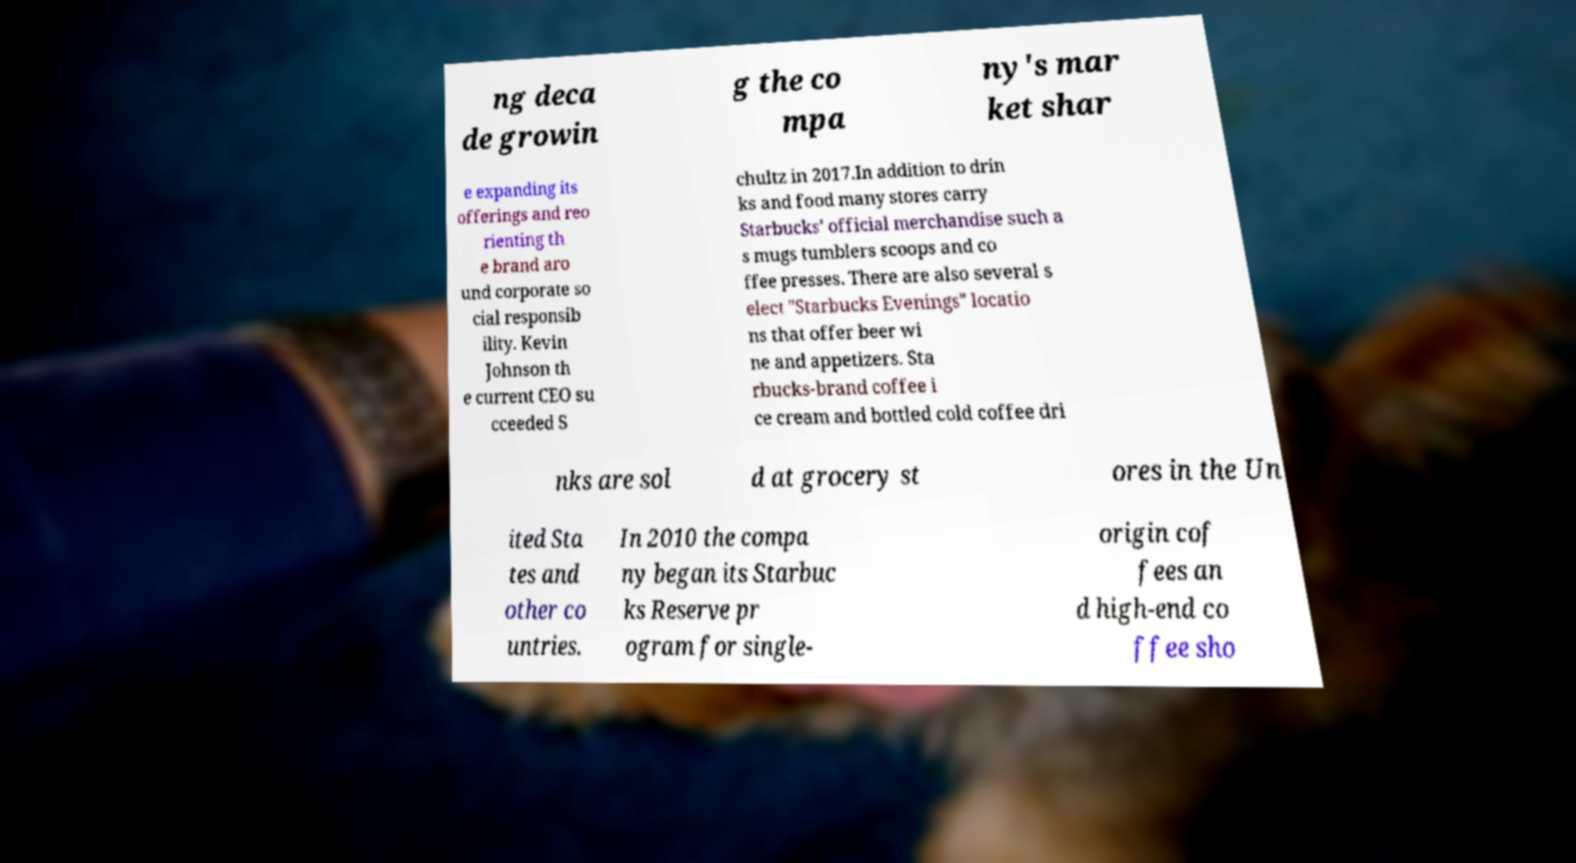Could you extract and type out the text from this image? ng deca de growin g the co mpa ny's mar ket shar e expanding its offerings and reo rienting th e brand aro und corporate so cial responsib ility. Kevin Johnson th e current CEO su cceeded S chultz in 2017.In addition to drin ks and food many stores carry Starbucks' official merchandise such a s mugs tumblers scoops and co ffee presses. There are also several s elect "Starbucks Evenings" locatio ns that offer beer wi ne and appetizers. Sta rbucks-brand coffee i ce cream and bottled cold coffee dri nks are sol d at grocery st ores in the Un ited Sta tes and other co untries. In 2010 the compa ny began its Starbuc ks Reserve pr ogram for single- origin cof fees an d high-end co ffee sho 